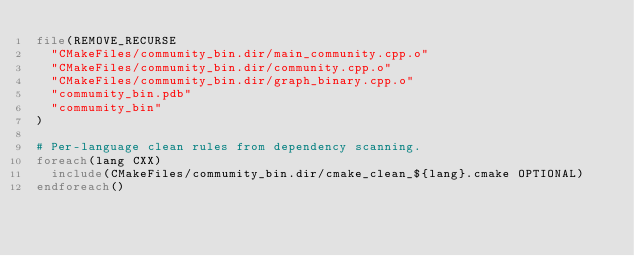Convert code to text. <code><loc_0><loc_0><loc_500><loc_500><_CMake_>file(REMOVE_RECURSE
  "CMakeFiles/commumity_bin.dir/main_community.cpp.o"
  "CMakeFiles/commumity_bin.dir/community.cpp.o"
  "CMakeFiles/commumity_bin.dir/graph_binary.cpp.o"
  "commumity_bin.pdb"
  "commumity_bin"
)

# Per-language clean rules from dependency scanning.
foreach(lang CXX)
  include(CMakeFiles/commumity_bin.dir/cmake_clean_${lang}.cmake OPTIONAL)
endforeach()
</code> 